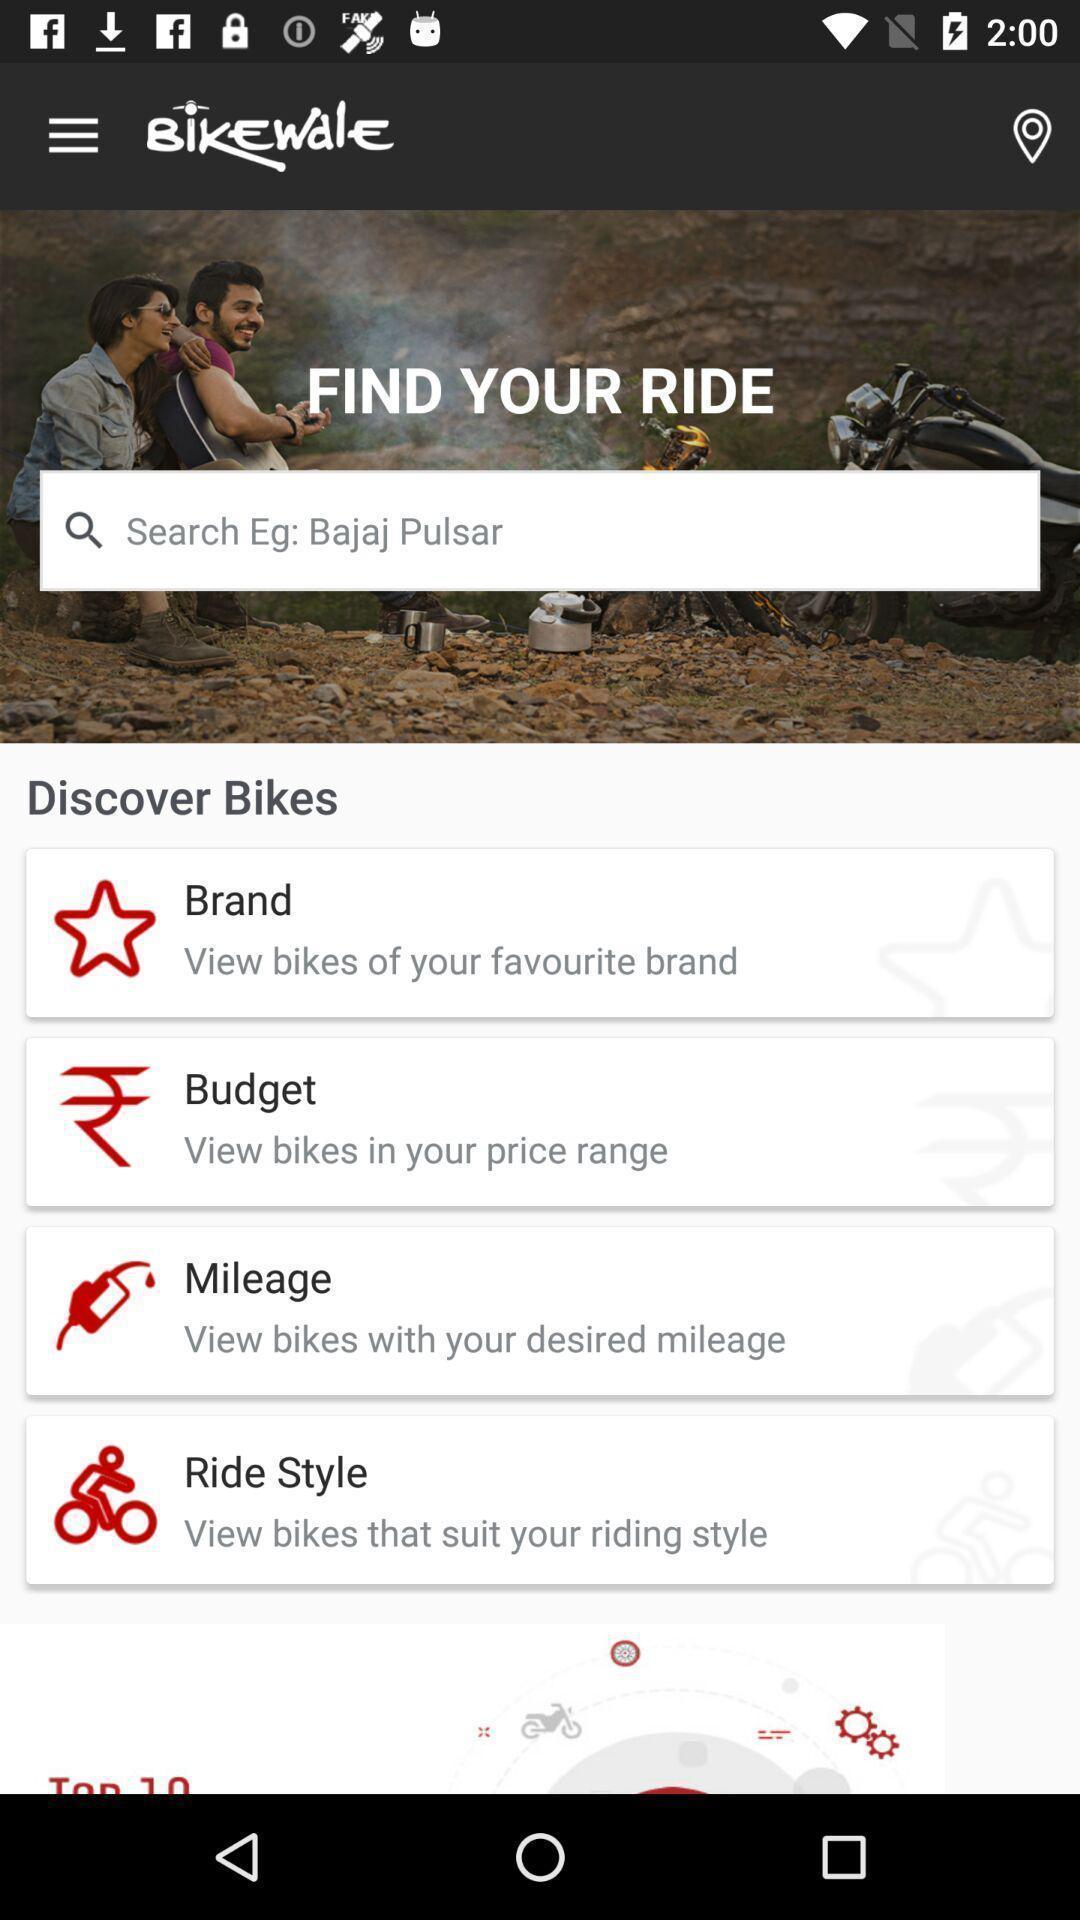Tell me about the visual elements in this screen capture. Search page of online bike shopping app. 